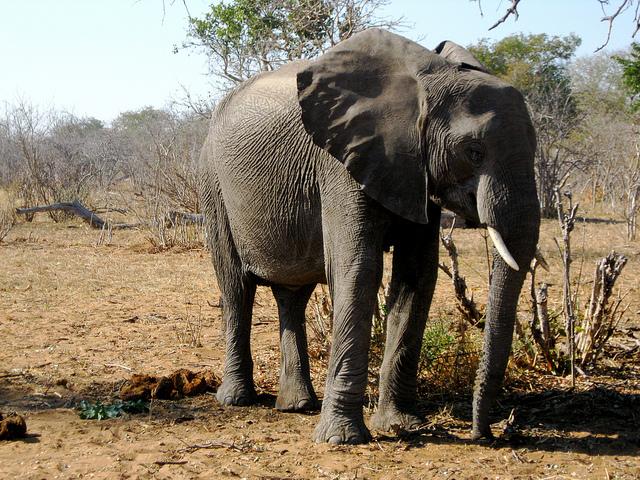Why is the elephant just standing there?
Keep it brief. Resting. Is this the elephant's natural habitat?
Keep it brief. Yes. Is there a baby elephants?
Be succinct. No. What animal is the picture?
Write a very short answer. Elephant. Is this a desert?
Quick response, please. Yes. Is there a large stone enclosure?
Be succinct. No. Can you see any cars in the picture?
Answer briefly. No. What kind of terrain is depicted?
Give a very brief answer. Dirt. Is there water nearby?
Write a very short answer. No. Is this a young animal?
Answer briefly. No. Which is bigger for this animal, the tail or the nose?
Answer briefly. Nose. Is there lots of vegetation for the elephant to eat?
Keep it brief. No. Is the animal in its natural habitat or captivity?
Quick response, please. Natural. Is the elephant in the wild or captivity?
Write a very short answer. Wild. What kind of trees are these?
Be succinct. Oak. 